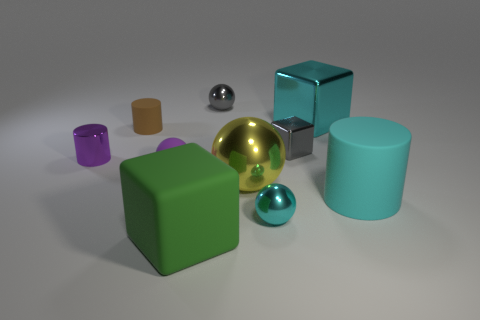How do the shadows cast by the objects inform us about the light source in this image? The shadows cast by the objects in the image are relatively soft and spread out to the lower right of each object, suggesting the light source is positioned to the top left of the scene, possibly out of frame. The direction and softness of the shadows indicate there may be a single, diffuse light source illuminating the objects.  Can you describe the texture of the objects in the image? From the image, the objects appear to have a smooth and reflective texture, particularly noticeable on the metallic sphere and the cyan cube. These textures provide a visual impression of materials like polished plastic or metal, enhancing the realistic quality of the scene. 